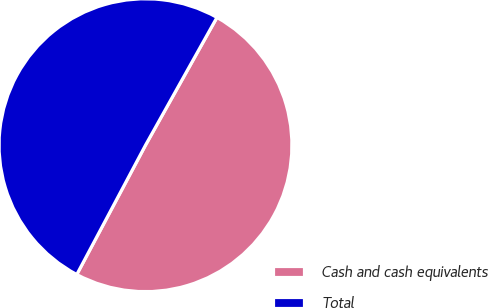Convert chart to OTSL. <chart><loc_0><loc_0><loc_500><loc_500><pie_chart><fcel>Cash and cash equivalents<fcel>Total<nl><fcel>49.66%<fcel>50.34%<nl></chart> 